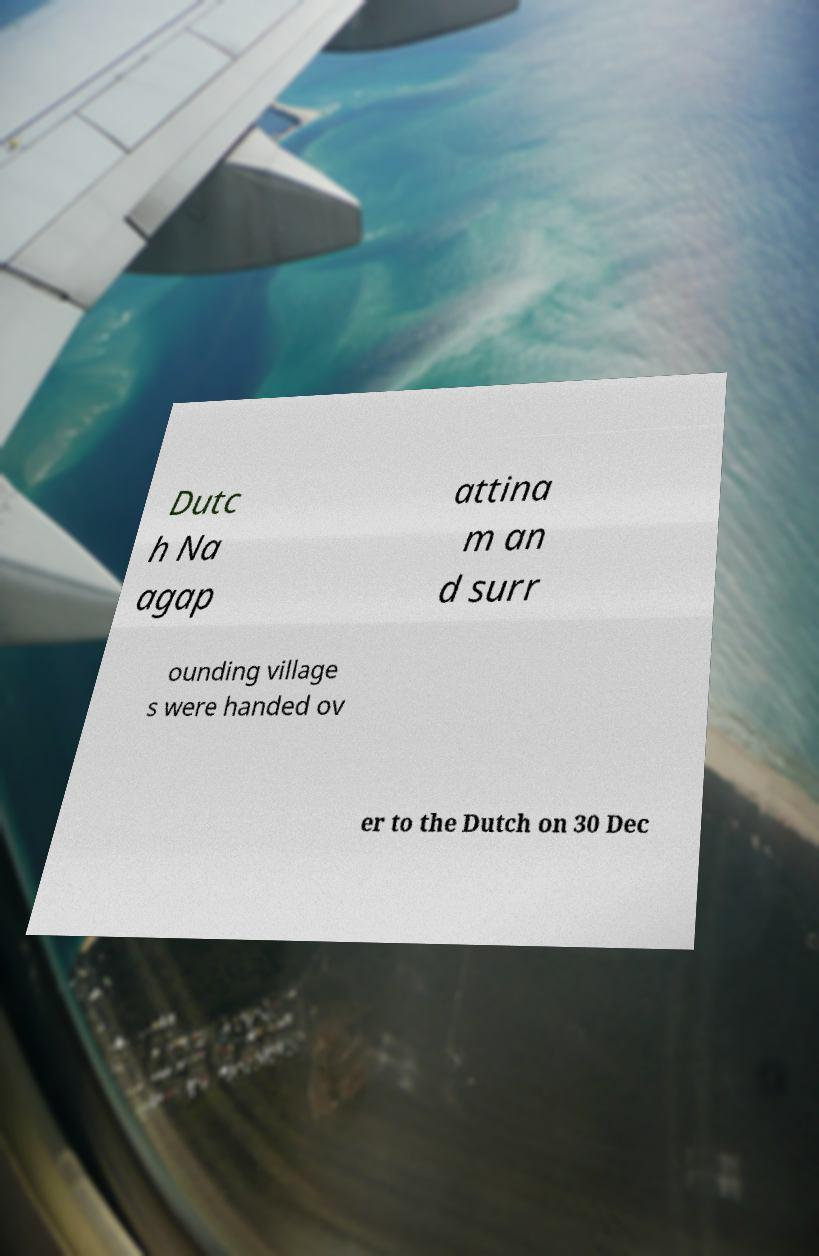I need the written content from this picture converted into text. Can you do that? Dutc h Na agap attina m an d surr ounding village s were handed ov er to the Dutch on 30 Dec 